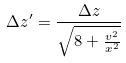Convert formula to latex. <formula><loc_0><loc_0><loc_500><loc_500>\Delta z ^ { \prime } = \frac { \Delta z } { \sqrt { 8 + \frac { v ^ { 2 } } { x ^ { 2 } } } }</formula> 